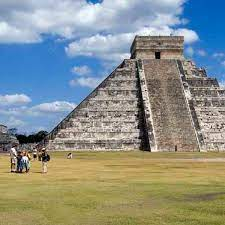What scenarios could depict a day in the life of a Mayan at Chichen Itza? A day in the life of a Mayan at Chichen Itza would be vibrant and filled with a blend of religious, social, and economic activities. Early in the morning, you might participate in a communal ritual at the Temple of Kukulkan, offering food and prayers to ensure a bountiful harvest. As the sun rises higher, the marketplace around the pyramid becomes bustling with traders and artisans, exchanging goods such as woven fabrics, pottery, and jade jewelry. Midday could involve attending or participating in a game at the Great Ball Court, an event that is both sport and religious ceremony, symbolizing the eternal battle between darkness and light. In the afternoon, scholarly Mayans might engage in observations at the Caracol to track celestial movements, while others attend to the surrounding agricultural fields. As evening approaches, there might be storytelling sessions where elders recite tales of gods, ancestors, and the cosmos, fostering a strong sense of community and continuity. The day may end with a procession of priests and acolytes making their way to the platform of the pyramid, lighting torches as they prepare for a night-time ceremony honoring the stars above.  Describe briefly the everyday scenes around the pyramid. Everyday scenes around the pyramid would likely involve a mix of rituals, commerce, and social gatherings. Priests conducting ceremonies at the temple, traders selling their wares in bustling markets, children playing and learning the stories of their ancestors, and laborers maintaining the fields and infrastructure. The air would be filled with the sounds of music, the chatter of people, and the occasional cry of wildlife, creating a vibrant and dynamic environment around this central hub of Mayan life. 